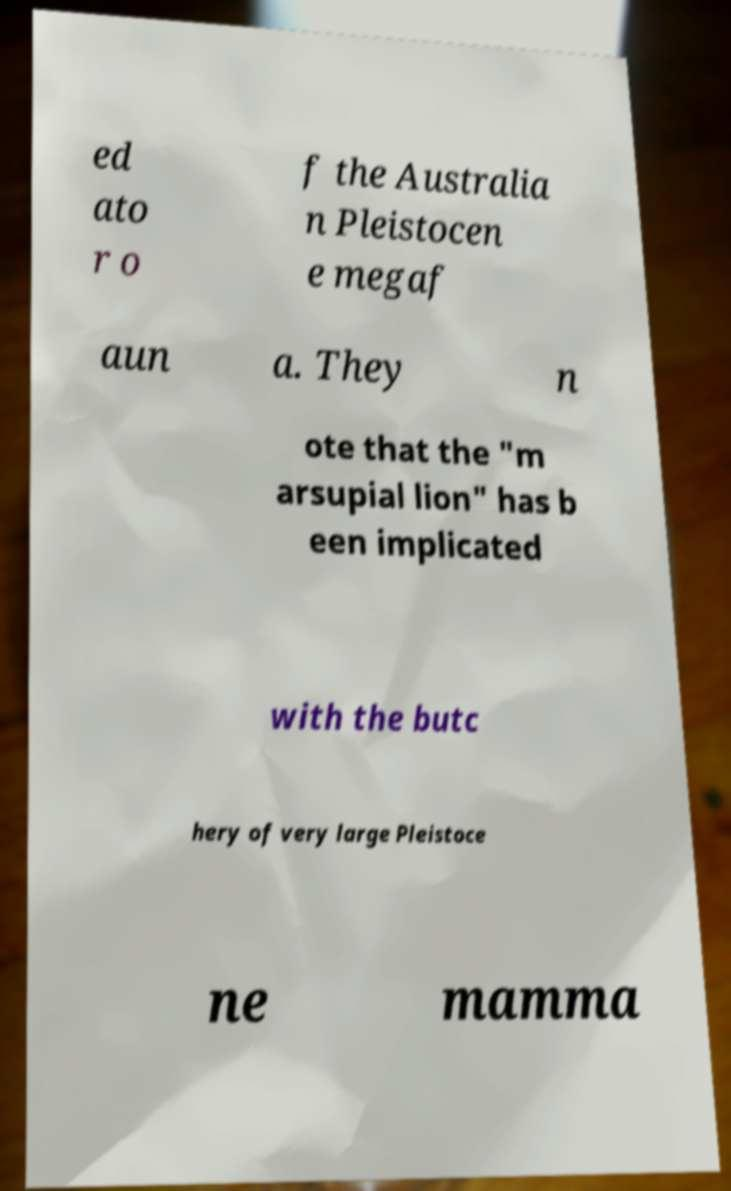Can you read and provide the text displayed in the image?This photo seems to have some interesting text. Can you extract and type it out for me? ed ato r o f the Australia n Pleistocen e megaf aun a. They n ote that the "m arsupial lion" has b een implicated with the butc hery of very large Pleistoce ne mamma 